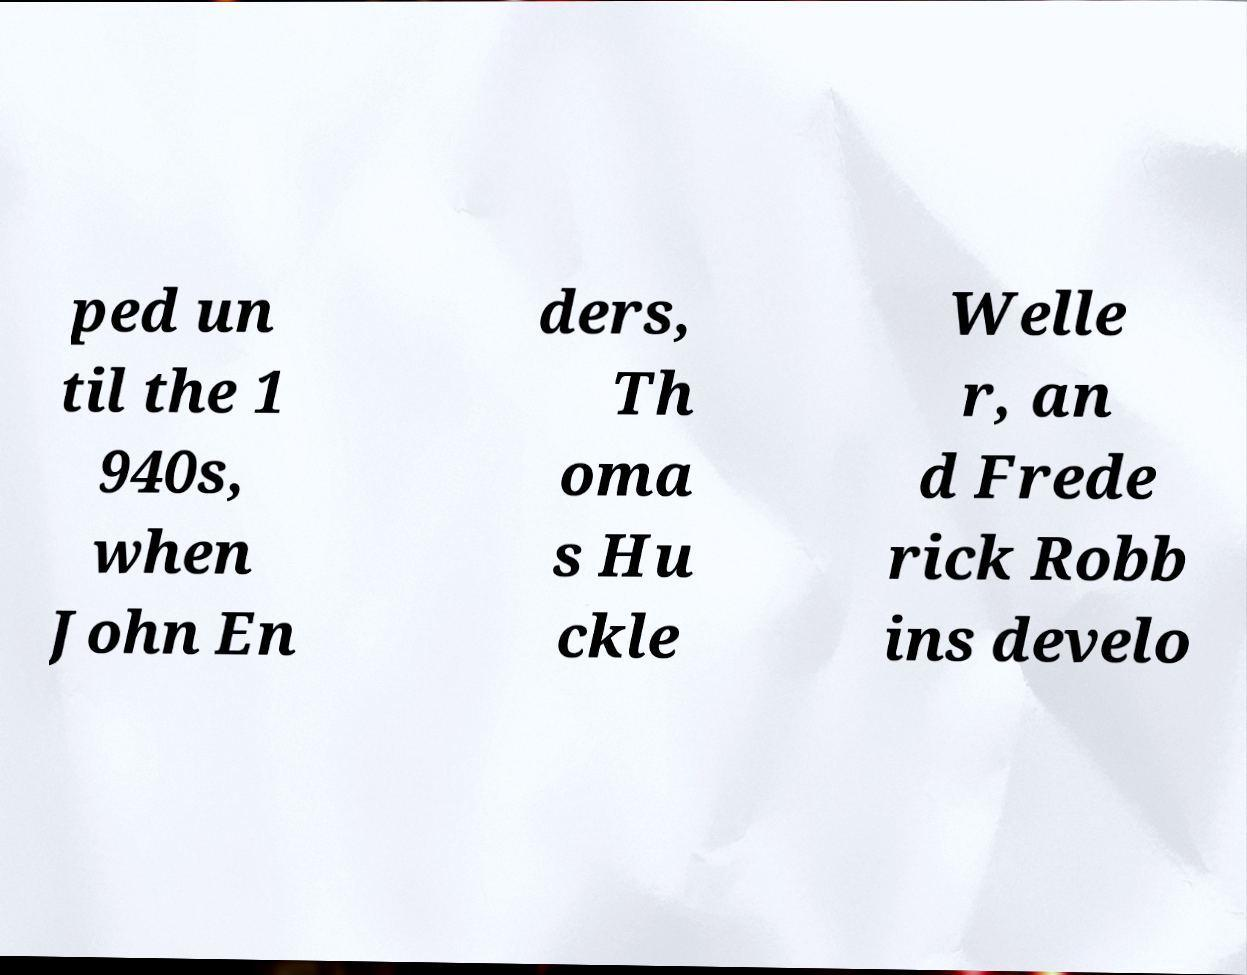What messages or text are displayed in this image? I need them in a readable, typed format. ped un til the 1 940s, when John En ders, Th oma s Hu ckle Welle r, an d Frede rick Robb ins develo 